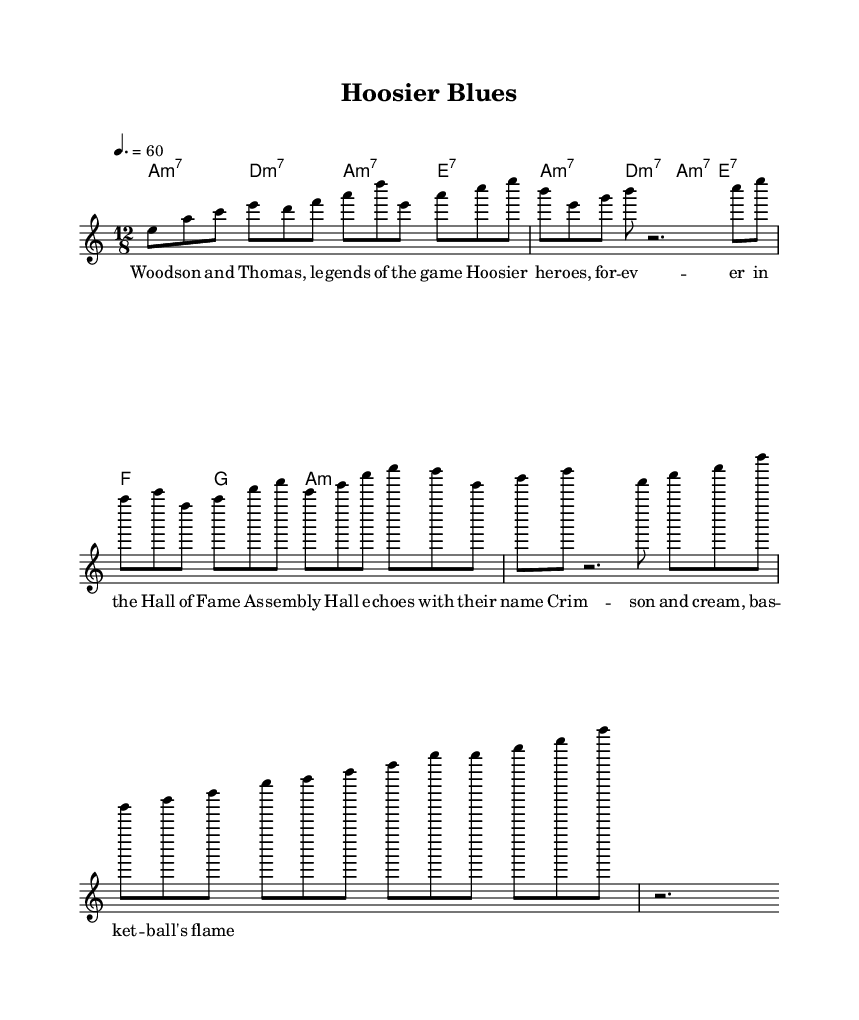What is the key signature of this music? The key signature indicates that the piece is in A minor, which has no sharps or flats. This can be derived from the key specified in the global block of the LilyPond code.
Answer: A minor What is the time signature of this music? The time signature, indicated in the global block, is 12/8. This means there are twelve beats in a measure, and the eighth note gets one beat.
Answer: 12/8 What is the tempo marking for this piece? The tempo marking in the global block specifies 60 beats per minute, indicated as "4. = 60." This suggests a moderate slow pace typical of blues music.
Answer: 60 How many measures are there in the chorus? The chorus is composed of a total of four measures, as indicated by the structure given in the harmony and lyrics blocks. Each measure aligns with the melody presented.
Answer: 4 What is the first lyric line of the verse? The first line of the verse as per the lyric mode is "Wood -- son and Tho -- mas, le -- gends of the game." This can be directly referenced from the lyric block of the code.
Answer: Woodson and Thomas, legends of the game What style of music does this piece represent? The piece is categorized as "Electric Blues," characterized by slow, soulful ballads that reflect on basketball legends, correlating with the themes in the lyrics and the style of the music.
Answer: Electric Blues Which specific basketball legends are referenced in the lyrics? The lyrics mention "Woodson and Thomas," referring to Mike Woodson and Isiah Thomas, indicating the tribute to these basketball legends within the song content.
Answer: Woodson and Thomas 